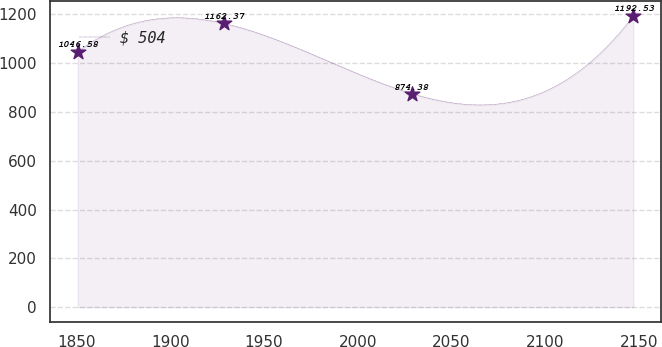<chart> <loc_0><loc_0><loc_500><loc_500><line_chart><ecel><fcel>$ 504<nl><fcel>1850.71<fcel>1046.58<nl><fcel>1928.49<fcel>1162.37<nl><fcel>2028.96<fcel>874.38<nl><fcel>2147.08<fcel>1192.53<nl></chart> 